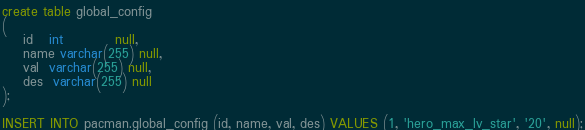<code> <loc_0><loc_0><loc_500><loc_500><_SQL_>create table global_config
(
    id   int          null,
    name varchar(255) null,
    val  varchar(255) null,
    des  varchar(255) null
);

INSERT INTO pacman.global_config (id, name, val, des) VALUES (1, 'hero_max_lv_star', '20', null);</code> 